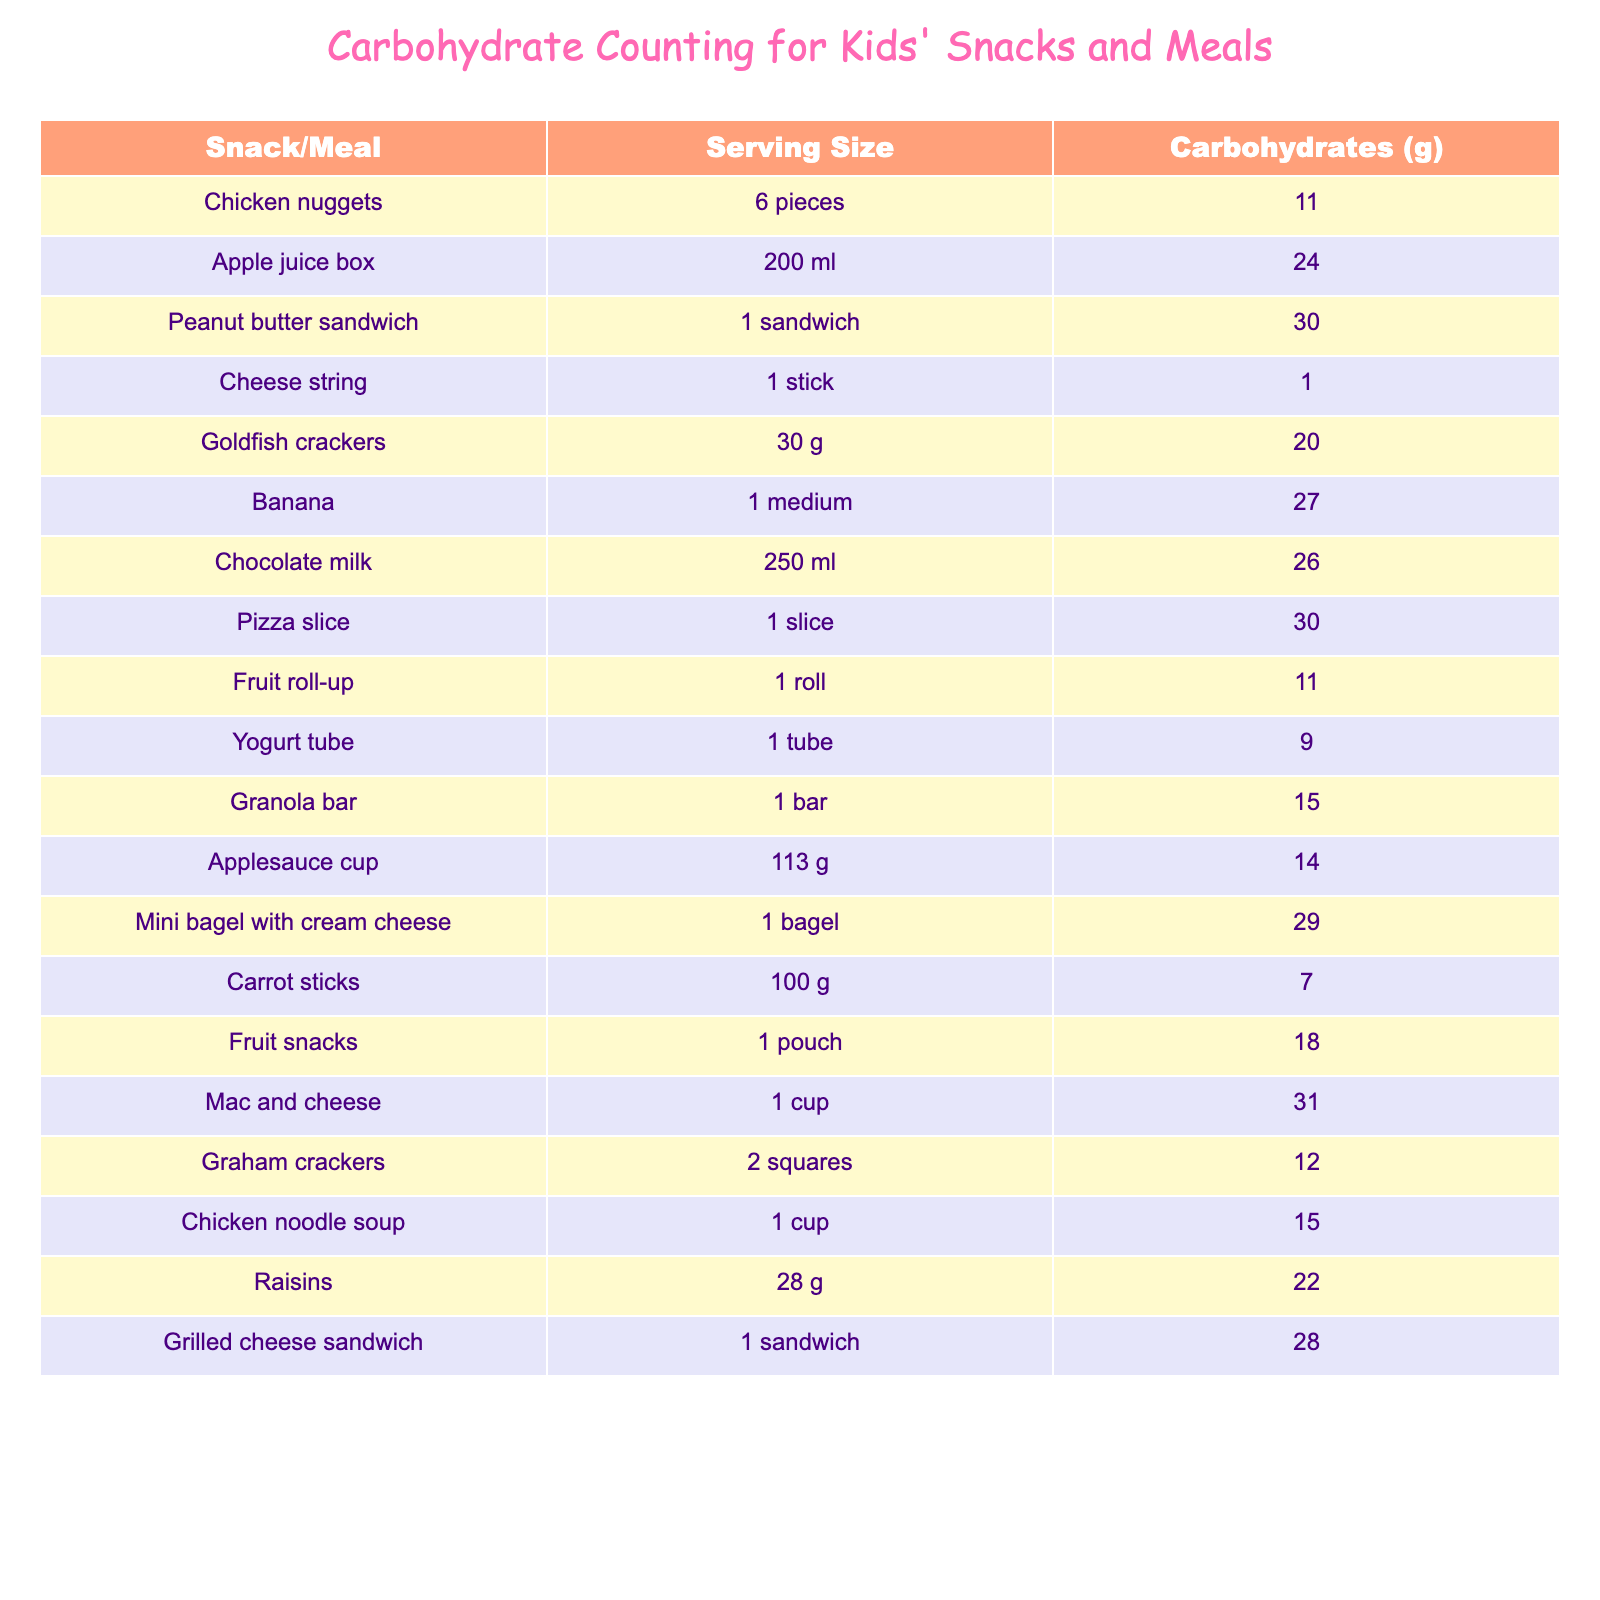What is the carbohydrate content of a peanut butter sandwich? The table shows the carbohydrate content for various snacks and meals. By looking for "Peanut butter sandwich" in the "Snack/Meal" column, I find that it has 30 grams of carbohydrates listed next to it.
Answer: 30 grams Which snack contains the least carbohydrates? The table lists the carbohydrate values for several foods. Scanning through the "Carbohydrates (g)" column, I see that "Cheese string" has the lowest value at 1 gram.
Answer: Cheese string How many carbohydrates are in a chocolate milk? By checking the "Snack/Meal" column, I find "Chocolate milk" and look at its corresponding carbohydrate content in the next column, which shows 26 grams.
Answer: 26 grams If I have a banana and a fruit roll-up, what is the total carbohydrate content? First, locate "Banana" which has 27 grams of carbohydrates, and then find "Fruit roll-up" which has 11 grams. Adding these together: 27 + 11 = 38 grams.
Answer: 38 grams Is a serving of mac and cheese higher in carbohydrates than a peanut butter sandwich? Looking at "Mac and cheese," it has 31 grams, while "Peanut butter sandwich" has 30 grams. Since 31 grams is greater than 30 grams, the answer is yes.
Answer: Yes What is the average carbohydrate content of chicken nuggets and chicken noodle soup? I find "Chicken nuggets" has 11 grams and "Chicken noodle soup" has 15 grams. To find the average, I add the two: 11 + 15 = 26 grams, then divide by 2: 26/2 = 13 grams.
Answer: 13 grams Which snack has more carbohydrates, goldfish crackers or raisins? Goldfish crackers have 20 grams of carbohydrates and raisins have 22 grams. Since 22 is greater than 20, raisins contain more carbohydrates.
Answer: Raisins If I eat a mini bagel with cream cheese and a granola bar, what is the total carbohydrate content? The mini bagel with cream cheese has 29 grams and the granola bar has 15 grams. Adding these two values gives 29 + 15 = 44 grams.
Answer: 44 grams Is it true that a pizza slice and a grilled cheese sandwich together have more than 60 grams of carbohydrates? A pizza slice has 30 grams and a grilled cheese sandwich has 28 grams. Adding these gives 30 + 28 = 58 grams, which is less than 60 grams. Therefore, the statement is false.
Answer: False What snack has exactly 20 grams of carbohydrates? By reviewing the table, "Goldfish crackers" shows 20 grams of carbohydrates. Therefore, this snack meets the requirement.
Answer: Goldfish crackers 